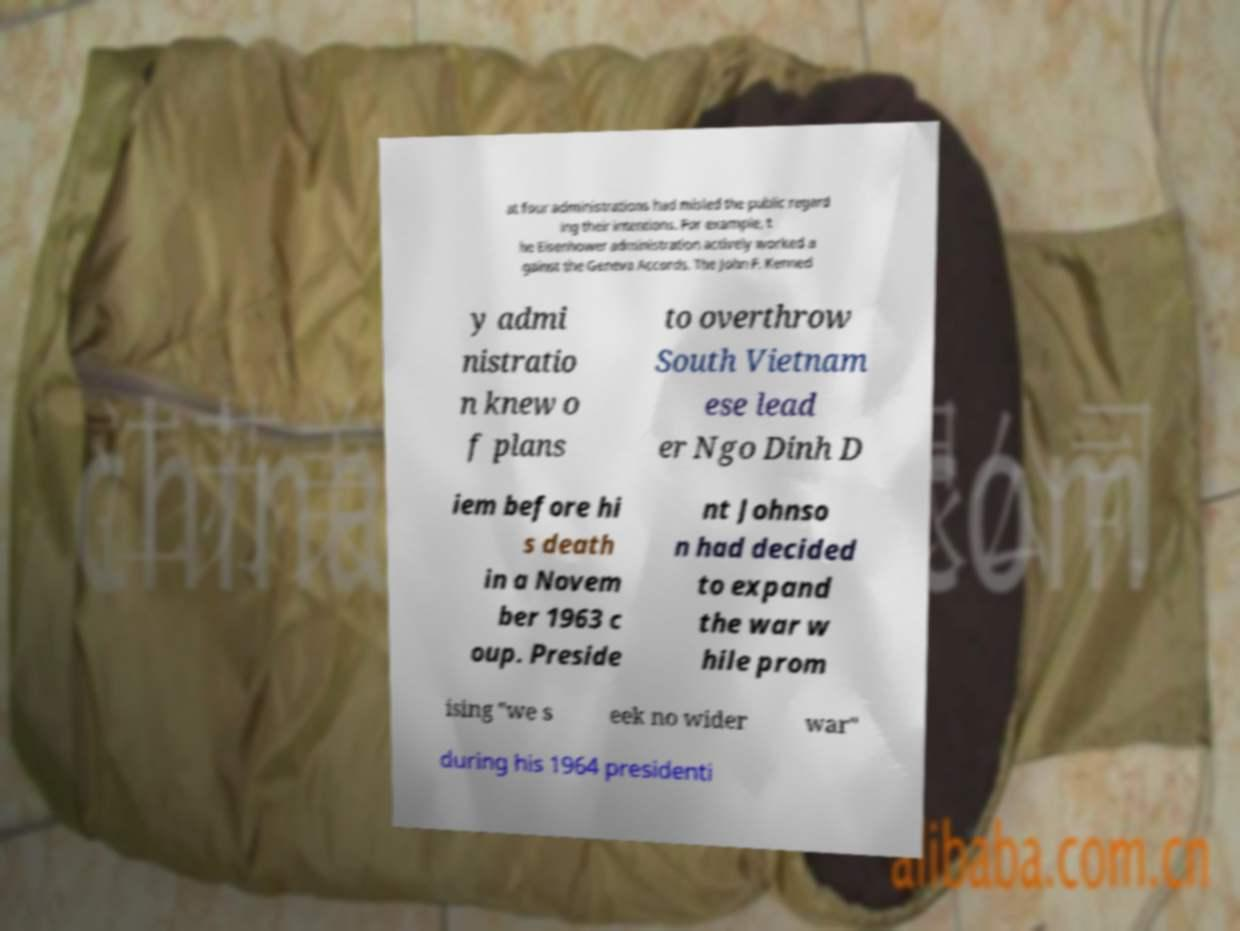Can you accurately transcribe the text from the provided image for me? at four administrations had misled the public regard ing their intentions. For example, t he Eisenhower administration actively worked a gainst the Geneva Accords. The John F. Kenned y admi nistratio n knew o f plans to overthrow South Vietnam ese lead er Ngo Dinh D iem before hi s death in a Novem ber 1963 c oup. Preside nt Johnso n had decided to expand the war w hile prom ising "we s eek no wider war" during his 1964 presidenti 